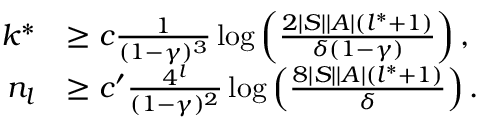Convert formula to latex. <formula><loc_0><loc_0><loc_500><loc_500>\begin{array} { r l } { k ^ { * } } & { \geq c \frac { 1 } { ( 1 - \gamma ) ^ { 3 } } \log \left ( \frac { 2 | S | | A | ( l ^ { * } + 1 ) } { \delta ( 1 - \gamma ) } \right ) , } \\ { n _ { l } } & { \geq c ^ { \prime } \frac { 4 ^ { l } } { ( 1 - \gamma ) ^ { 2 } } \log \left ( \frac { 8 | S | | A | ( l ^ { * } + 1 ) } { \delta } \right ) . } \end{array}</formula> 